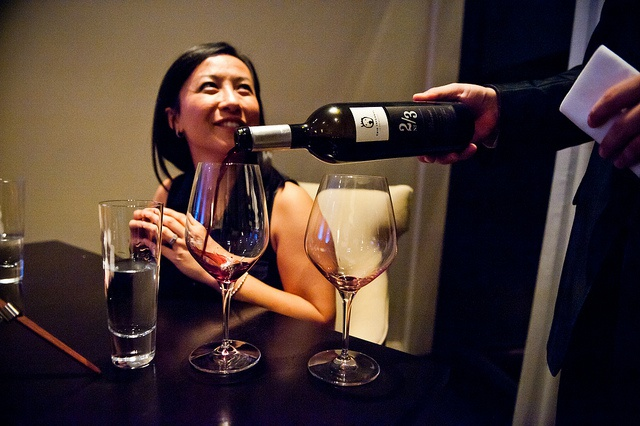Describe the objects in this image and their specific colors. I can see dining table in black, maroon, and gray tones, people in black, gray, maroon, and darkgray tones, people in black, maroon, tan, and brown tones, wine glass in black, maroon, and brown tones, and bottle in black, ivory, maroon, and gray tones in this image. 